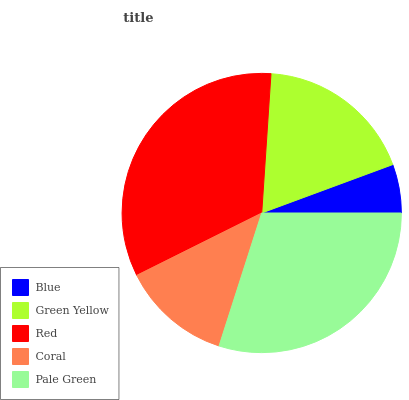Is Blue the minimum?
Answer yes or no. Yes. Is Red the maximum?
Answer yes or no. Yes. Is Green Yellow the minimum?
Answer yes or no. No. Is Green Yellow the maximum?
Answer yes or no. No. Is Green Yellow greater than Blue?
Answer yes or no. Yes. Is Blue less than Green Yellow?
Answer yes or no. Yes. Is Blue greater than Green Yellow?
Answer yes or no. No. Is Green Yellow less than Blue?
Answer yes or no. No. Is Green Yellow the high median?
Answer yes or no. Yes. Is Green Yellow the low median?
Answer yes or no. Yes. Is Blue the high median?
Answer yes or no. No. Is Red the low median?
Answer yes or no. No. 